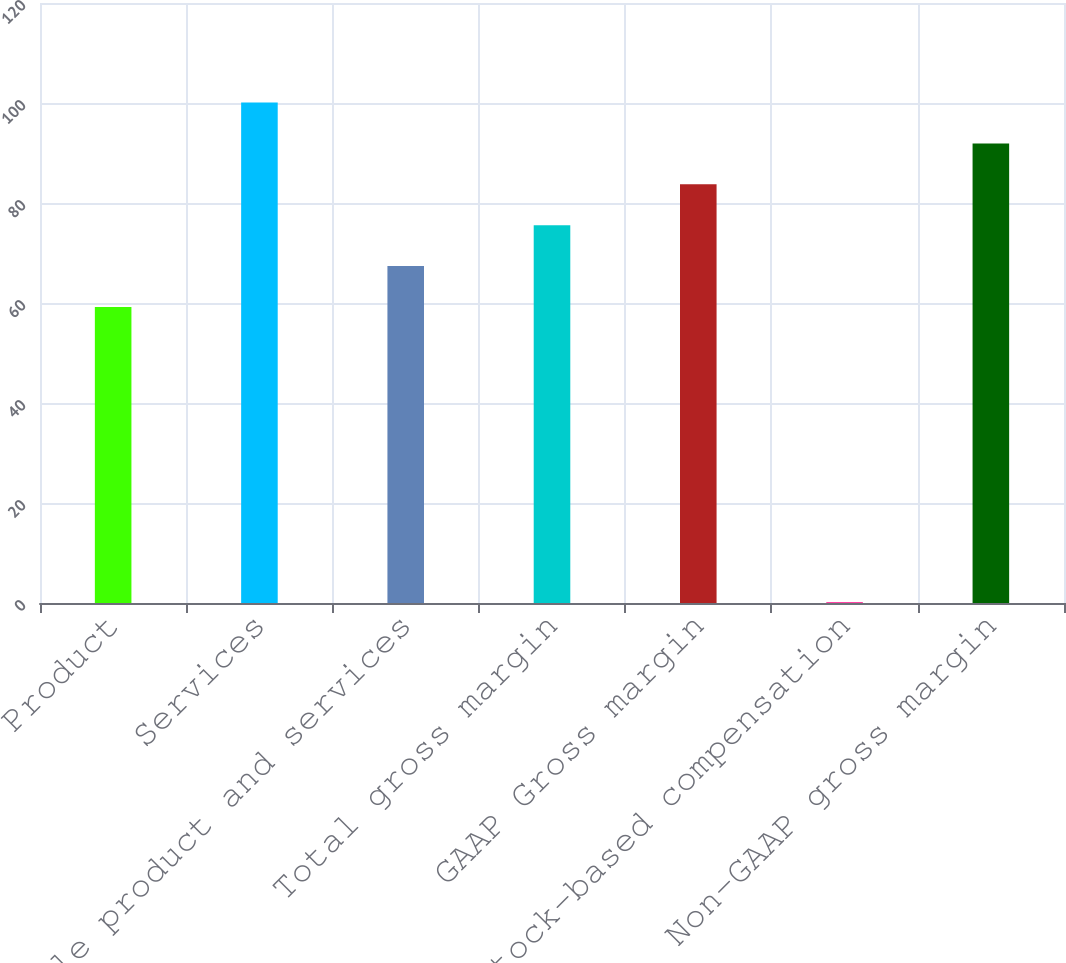Convert chart to OTSL. <chart><loc_0><loc_0><loc_500><loc_500><bar_chart><fcel>Product<fcel>Services<fcel>Ratable product and services<fcel>Total gross margin<fcel>GAAP Gross margin<fcel>Stock-based compensation<fcel>Non-GAAP gross margin<nl><fcel>59.2<fcel>100.1<fcel>67.38<fcel>75.56<fcel>83.74<fcel>0.2<fcel>91.92<nl></chart> 